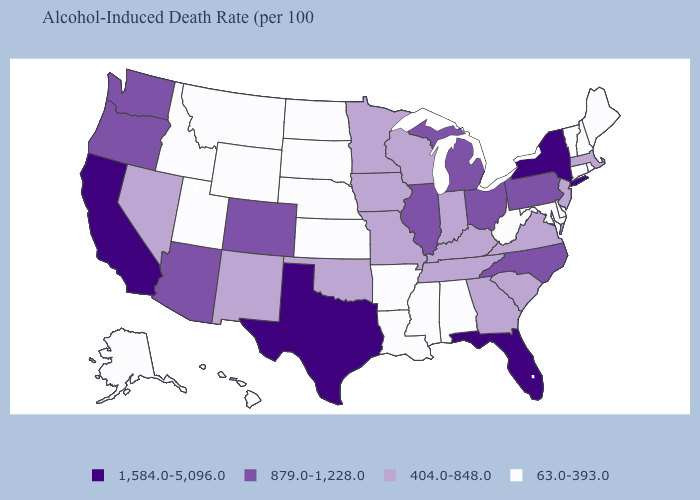Name the states that have a value in the range 1,584.0-5,096.0?
Write a very short answer. California, Florida, New York, Texas. Which states hav the highest value in the MidWest?
Short answer required. Illinois, Michigan, Ohio. What is the value of Vermont?
Answer briefly. 63.0-393.0. Which states have the lowest value in the West?
Be succinct. Alaska, Hawaii, Idaho, Montana, Utah, Wyoming. Does South Dakota have a lower value than Alaska?
Write a very short answer. No. Does South Carolina have a higher value than Alabama?
Short answer required. Yes. Name the states that have a value in the range 879.0-1,228.0?
Short answer required. Arizona, Colorado, Illinois, Michigan, North Carolina, Ohio, Oregon, Pennsylvania, Washington. Does Montana have the highest value in the USA?
Quick response, please. No. Which states hav the highest value in the Northeast?
Short answer required. New York. What is the value of California?
Be succinct. 1,584.0-5,096.0. Which states hav the highest value in the MidWest?
Concise answer only. Illinois, Michigan, Ohio. Among the states that border Pennsylvania , which have the lowest value?
Give a very brief answer. Delaware, Maryland, West Virginia. Name the states that have a value in the range 1,584.0-5,096.0?
Keep it brief. California, Florida, New York, Texas. Which states have the highest value in the USA?
Give a very brief answer. California, Florida, New York, Texas. 